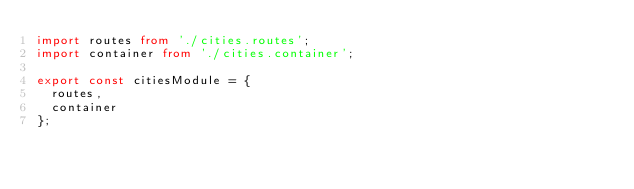<code> <loc_0><loc_0><loc_500><loc_500><_TypeScript_>import routes from './cities.routes';
import container from './cities.container';

export const citiesModule = {
  routes,
  container
};
</code> 